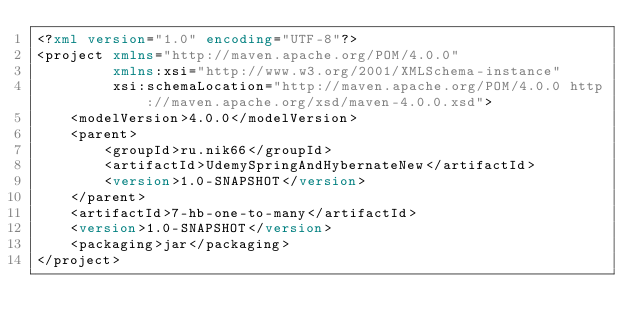Convert code to text. <code><loc_0><loc_0><loc_500><loc_500><_XML_><?xml version="1.0" encoding="UTF-8"?>
<project xmlns="http://maven.apache.org/POM/4.0.0"
         xmlns:xsi="http://www.w3.org/2001/XMLSchema-instance"
         xsi:schemaLocation="http://maven.apache.org/POM/4.0.0 http://maven.apache.org/xsd/maven-4.0.0.xsd">
    <modelVersion>4.0.0</modelVersion>
    <parent>
        <groupId>ru.nik66</groupId>
        <artifactId>UdemySpringAndHybernateNew</artifactId>
        <version>1.0-SNAPSHOT</version>
    </parent>
    <artifactId>7-hb-one-to-many</artifactId>
    <version>1.0-SNAPSHOT</version>
    <packaging>jar</packaging>
</project></code> 